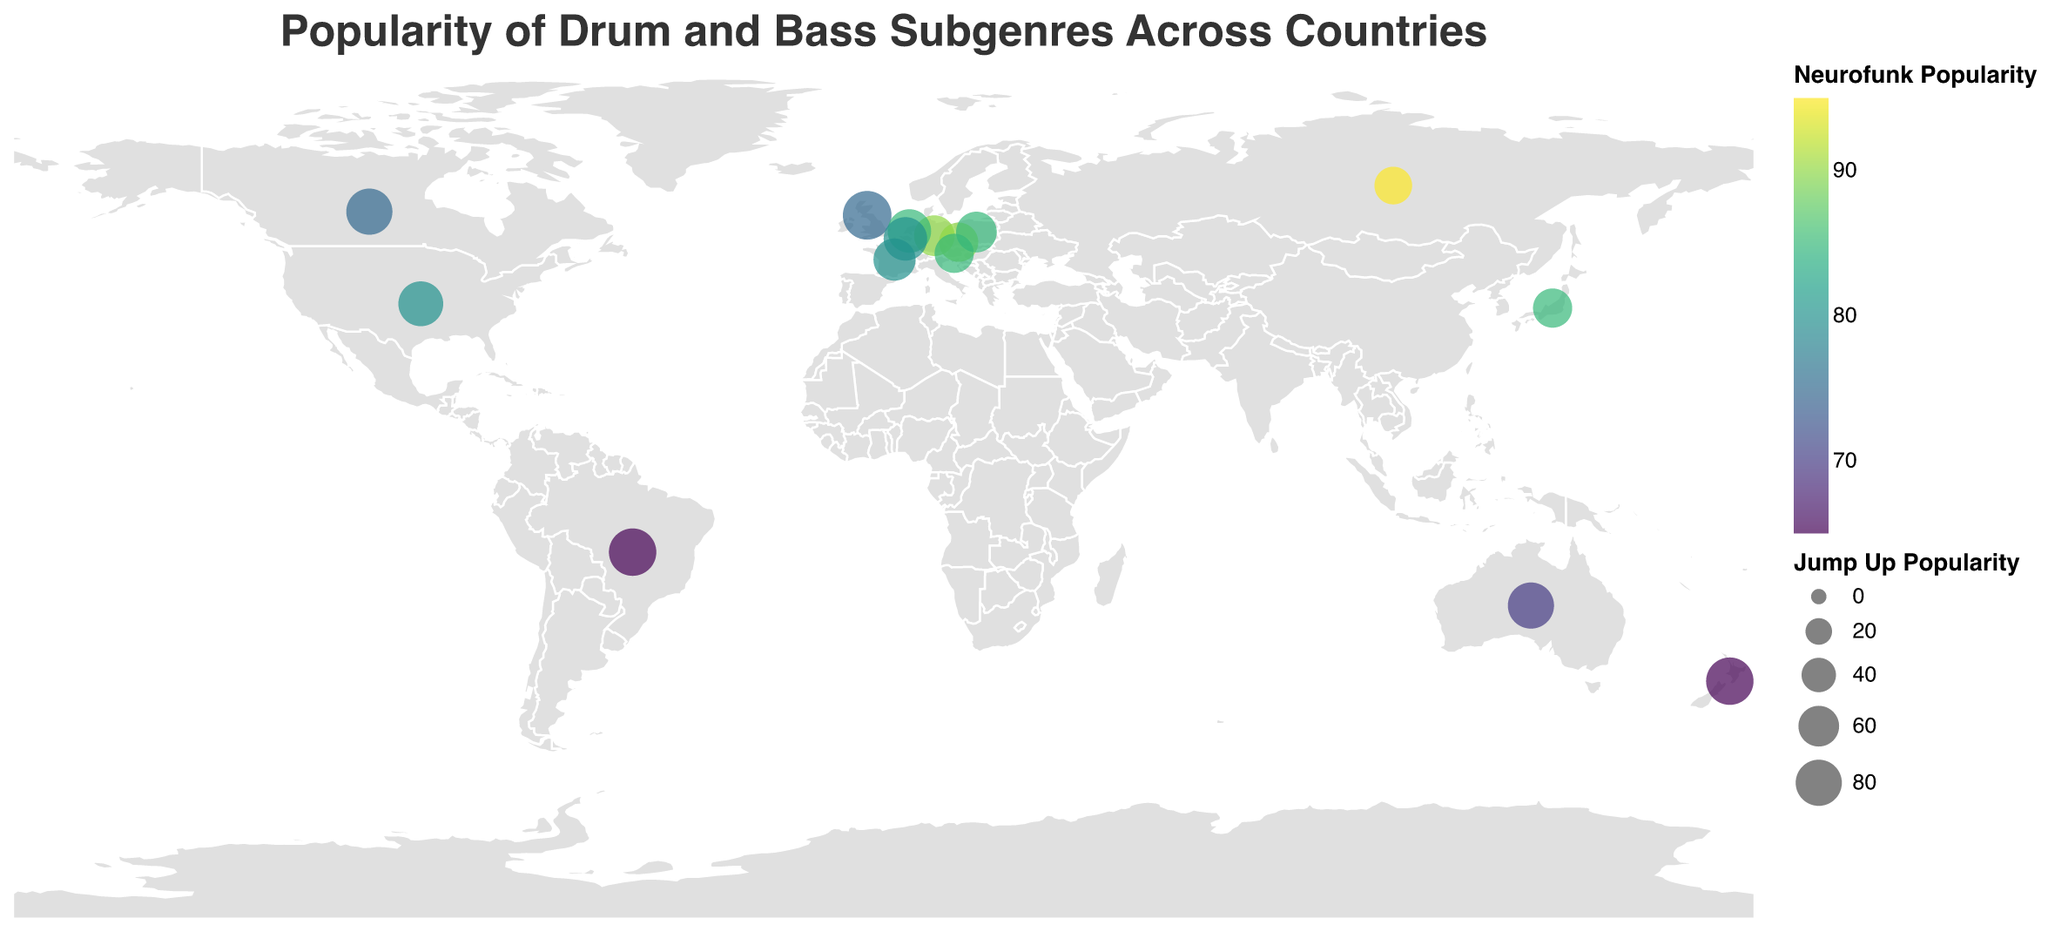What is the color scheme used for representing Neurofunk popularity on the map? The color scheme used is "viridis," which typically ranges from yellow to green to purple. We can infer this from the colors used in the legend for Neurofunk popularity.
Answer: viridis Which country has the highest popularity for Neurofunk? By looking at the color intensity on the map and the tooltip values, Russia has the highest value for Neurofunk with a score of 95.
Answer: Russia How does the popularity of Jump Up in the United Kingdom compare to that in Canada? The size of the circles indicates the popularity of Jump Up. The United Kingdom has a Jump Up popularity of 90, whereas Canada has a Jump Up popularity of 80 as noted in the tooltips.
Answer: United Kingdom's Jump Up is more popular What is the mean popularity of Liquid across all the countries? Sum the Liquid popularity of all countries and divide by the number of countries. (85 + 70 + 75 + 65 + 60 + 80 + 70 + 75 + 65 + 70 + 75 + 70 + 65 + 75 + 65) / 15 = 1070 / 15
Answer: 71.33 Which region has the most diversified popularity in the Liquid and Neurofunk subgenres? Europe has a variety of values for both Liquid (from 60 to 85) and Neurofunk (from 75 to 95), indicating high diversification in these subgenres.
Answer: Europe Are there any outliers in the popularity of Techstep across different countries? By examining the map and comparing the Techstep values, Russia (90) and Germany (85) stand out as outliers since they have higher values compared to other countries.
Answer: Russia and Germany Which country has the least popularity for Darkstep? Referencing the tooltips, the United States has the lowest popularity for Darkstep with a score of 55.
Answer: United States How many countries in total are represented on the plot? By counting the number of data points (circles) on the map, we see there are 15 countries represented.
Answer: 15 Which regions have shown at least a 70 popularity score in any subgenre? Analyze the tooltips for each region; Europe, North America, Oceania, Asia, and South America have all shown at least a 70 popularity score in one or more subgenres.
Answer: Europe, North America, Oceania, Asia, South America 